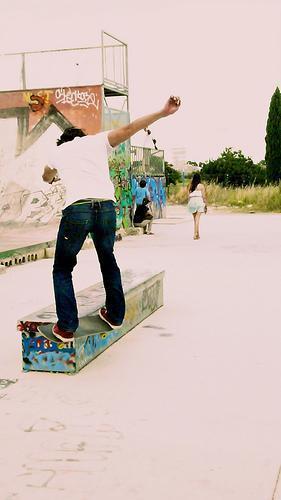How many skaters are there?
Give a very brief answer. 1. 